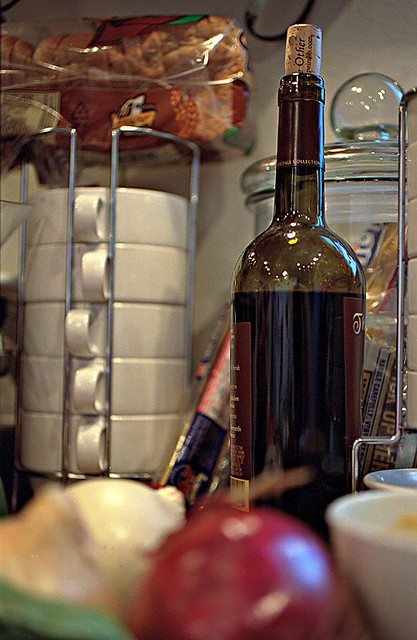Please identify all text content in this image. J 